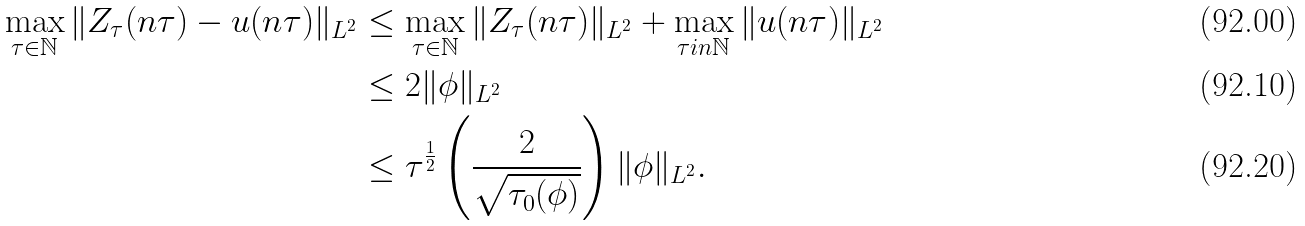<formula> <loc_0><loc_0><loc_500><loc_500>\max _ { \tau \in \mathbb { N } } \| Z _ { \tau } ( n \tau ) - u ( n \tau ) \| _ { L ^ { 2 } } & \leq \max _ { \tau \in \mathbb { N } } \| Z _ { \tau } ( n \tau ) \| _ { L ^ { 2 } } + \max _ { \tau i n \mathbb { N } } \| u ( n \tau ) \| _ { L ^ { 2 } } \\ & \leq 2 \| \phi \| _ { L ^ { 2 } } \\ & \leq \tau ^ { \frac { 1 } { 2 } } \left ( \frac { 2 } { \sqrt { \tau _ { 0 } ( \phi ) } } \right ) \| \phi \| _ { L ^ { 2 } } .</formula> 